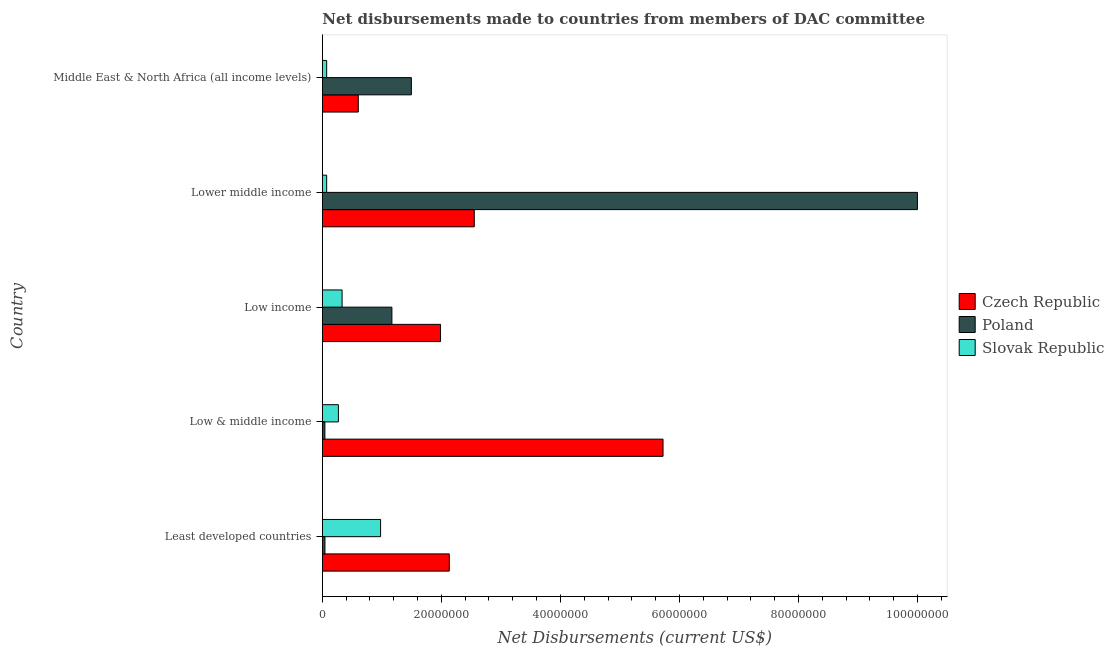How many groups of bars are there?
Your answer should be compact. 5. Are the number of bars per tick equal to the number of legend labels?
Your answer should be very brief. Yes. How many bars are there on the 3rd tick from the top?
Give a very brief answer. 3. How many bars are there on the 3rd tick from the bottom?
Your response must be concise. 3. What is the label of the 1st group of bars from the top?
Your answer should be very brief. Middle East & North Africa (all income levels). In how many cases, is the number of bars for a given country not equal to the number of legend labels?
Provide a short and direct response. 0. What is the net disbursements made by czech republic in Low income?
Provide a succinct answer. 1.99e+07. Across all countries, what is the maximum net disbursements made by czech republic?
Your response must be concise. 5.72e+07. Across all countries, what is the minimum net disbursements made by poland?
Ensure brevity in your answer.  4.30e+05. In which country was the net disbursements made by czech republic maximum?
Provide a short and direct response. Low & middle income. In which country was the net disbursements made by czech republic minimum?
Your answer should be compact. Middle East & North Africa (all income levels). What is the total net disbursements made by czech republic in the graph?
Your response must be concise. 1.30e+08. What is the difference between the net disbursements made by poland in Least developed countries and that in Low income?
Your answer should be very brief. -1.12e+07. What is the difference between the net disbursements made by poland in Least developed countries and the net disbursements made by slovak republic in Middle East & North Africa (all income levels)?
Make the answer very short. -2.90e+05. What is the average net disbursements made by czech republic per country?
Keep it short and to the point. 2.60e+07. What is the difference between the net disbursements made by czech republic and net disbursements made by poland in Low & middle income?
Provide a short and direct response. 5.68e+07. What is the ratio of the net disbursements made by slovak republic in Least developed countries to that in Low & middle income?
Offer a terse response. 3.63. What is the difference between the highest and the second highest net disbursements made by poland?
Ensure brevity in your answer.  8.50e+07. What is the difference between the highest and the lowest net disbursements made by poland?
Offer a very short reply. 9.96e+07. In how many countries, is the net disbursements made by poland greater than the average net disbursements made by poland taken over all countries?
Give a very brief answer. 1. Is the sum of the net disbursements made by czech republic in Low income and Middle East & North Africa (all income levels) greater than the maximum net disbursements made by slovak republic across all countries?
Provide a short and direct response. Yes. What does the 2nd bar from the bottom in Low & middle income represents?
Offer a very short reply. Poland. Are all the bars in the graph horizontal?
Ensure brevity in your answer.  Yes. Are the values on the major ticks of X-axis written in scientific E-notation?
Make the answer very short. No. How many legend labels are there?
Your response must be concise. 3. How are the legend labels stacked?
Offer a terse response. Vertical. What is the title of the graph?
Keep it short and to the point. Net disbursements made to countries from members of DAC committee. Does "Maunufacturing" appear as one of the legend labels in the graph?
Your answer should be very brief. No. What is the label or title of the X-axis?
Offer a terse response. Net Disbursements (current US$). What is the Net Disbursements (current US$) in Czech Republic in Least developed countries?
Your response must be concise. 2.13e+07. What is the Net Disbursements (current US$) in Slovak Republic in Least developed countries?
Your answer should be very brief. 9.79e+06. What is the Net Disbursements (current US$) of Czech Republic in Low & middle income?
Provide a succinct answer. 5.72e+07. What is the Net Disbursements (current US$) in Poland in Low & middle income?
Your answer should be very brief. 4.30e+05. What is the Net Disbursements (current US$) in Slovak Republic in Low & middle income?
Your answer should be very brief. 2.70e+06. What is the Net Disbursements (current US$) of Czech Republic in Low income?
Your answer should be compact. 1.99e+07. What is the Net Disbursements (current US$) in Poland in Low income?
Keep it short and to the point. 1.17e+07. What is the Net Disbursements (current US$) in Slovak Republic in Low income?
Offer a very short reply. 3.32e+06. What is the Net Disbursements (current US$) of Czech Republic in Lower middle income?
Keep it short and to the point. 2.55e+07. What is the Net Disbursements (current US$) in Poland in Lower middle income?
Offer a terse response. 1.00e+08. What is the Net Disbursements (current US$) in Slovak Republic in Lower middle income?
Offer a terse response. 7.30e+05. What is the Net Disbursements (current US$) in Czech Republic in Middle East & North Africa (all income levels)?
Ensure brevity in your answer.  6.04e+06. What is the Net Disbursements (current US$) of Poland in Middle East & North Africa (all income levels)?
Provide a short and direct response. 1.50e+07. What is the Net Disbursements (current US$) of Slovak Republic in Middle East & North Africa (all income levels)?
Provide a short and direct response. 7.30e+05. Across all countries, what is the maximum Net Disbursements (current US$) of Czech Republic?
Keep it short and to the point. 5.72e+07. Across all countries, what is the maximum Net Disbursements (current US$) in Poland?
Your answer should be compact. 1.00e+08. Across all countries, what is the maximum Net Disbursements (current US$) in Slovak Republic?
Offer a very short reply. 9.79e+06. Across all countries, what is the minimum Net Disbursements (current US$) of Czech Republic?
Keep it short and to the point. 6.04e+06. Across all countries, what is the minimum Net Disbursements (current US$) of Slovak Republic?
Make the answer very short. 7.30e+05. What is the total Net Disbursements (current US$) in Czech Republic in the graph?
Provide a succinct answer. 1.30e+08. What is the total Net Disbursements (current US$) of Poland in the graph?
Ensure brevity in your answer.  1.28e+08. What is the total Net Disbursements (current US$) in Slovak Republic in the graph?
Your answer should be compact. 1.73e+07. What is the difference between the Net Disbursements (current US$) of Czech Republic in Least developed countries and that in Low & middle income?
Provide a short and direct response. -3.59e+07. What is the difference between the Net Disbursements (current US$) in Slovak Republic in Least developed countries and that in Low & middle income?
Ensure brevity in your answer.  7.09e+06. What is the difference between the Net Disbursements (current US$) in Czech Republic in Least developed countries and that in Low income?
Give a very brief answer. 1.47e+06. What is the difference between the Net Disbursements (current US$) in Poland in Least developed countries and that in Low income?
Keep it short and to the point. -1.12e+07. What is the difference between the Net Disbursements (current US$) of Slovak Republic in Least developed countries and that in Low income?
Ensure brevity in your answer.  6.47e+06. What is the difference between the Net Disbursements (current US$) in Czech Republic in Least developed countries and that in Lower middle income?
Your answer should be very brief. -4.20e+06. What is the difference between the Net Disbursements (current US$) of Poland in Least developed countries and that in Lower middle income?
Give a very brief answer. -9.95e+07. What is the difference between the Net Disbursements (current US$) in Slovak Republic in Least developed countries and that in Lower middle income?
Your answer should be very brief. 9.06e+06. What is the difference between the Net Disbursements (current US$) of Czech Republic in Least developed countries and that in Middle East & North Africa (all income levels)?
Provide a short and direct response. 1.53e+07. What is the difference between the Net Disbursements (current US$) of Poland in Least developed countries and that in Middle East & North Africa (all income levels)?
Provide a succinct answer. -1.45e+07. What is the difference between the Net Disbursements (current US$) in Slovak Republic in Least developed countries and that in Middle East & North Africa (all income levels)?
Provide a short and direct response. 9.06e+06. What is the difference between the Net Disbursements (current US$) in Czech Republic in Low & middle income and that in Low income?
Make the answer very short. 3.74e+07. What is the difference between the Net Disbursements (current US$) in Poland in Low & middle income and that in Low income?
Ensure brevity in your answer.  -1.13e+07. What is the difference between the Net Disbursements (current US$) of Slovak Republic in Low & middle income and that in Low income?
Your answer should be very brief. -6.20e+05. What is the difference between the Net Disbursements (current US$) of Czech Republic in Low & middle income and that in Lower middle income?
Offer a very short reply. 3.17e+07. What is the difference between the Net Disbursements (current US$) in Poland in Low & middle income and that in Lower middle income?
Make the answer very short. -9.96e+07. What is the difference between the Net Disbursements (current US$) in Slovak Republic in Low & middle income and that in Lower middle income?
Your response must be concise. 1.97e+06. What is the difference between the Net Disbursements (current US$) in Czech Republic in Low & middle income and that in Middle East & North Africa (all income levels)?
Keep it short and to the point. 5.12e+07. What is the difference between the Net Disbursements (current US$) in Poland in Low & middle income and that in Middle East & North Africa (all income levels)?
Offer a very short reply. -1.45e+07. What is the difference between the Net Disbursements (current US$) of Slovak Republic in Low & middle income and that in Middle East & North Africa (all income levels)?
Your answer should be compact. 1.97e+06. What is the difference between the Net Disbursements (current US$) of Czech Republic in Low income and that in Lower middle income?
Your answer should be compact. -5.67e+06. What is the difference between the Net Disbursements (current US$) in Poland in Low income and that in Lower middle income?
Offer a terse response. -8.83e+07. What is the difference between the Net Disbursements (current US$) in Slovak Republic in Low income and that in Lower middle income?
Make the answer very short. 2.59e+06. What is the difference between the Net Disbursements (current US$) of Czech Republic in Low income and that in Middle East & North Africa (all income levels)?
Ensure brevity in your answer.  1.38e+07. What is the difference between the Net Disbursements (current US$) of Poland in Low income and that in Middle East & North Africa (all income levels)?
Provide a succinct answer. -3.27e+06. What is the difference between the Net Disbursements (current US$) in Slovak Republic in Low income and that in Middle East & North Africa (all income levels)?
Give a very brief answer. 2.59e+06. What is the difference between the Net Disbursements (current US$) in Czech Republic in Lower middle income and that in Middle East & North Africa (all income levels)?
Make the answer very short. 1.95e+07. What is the difference between the Net Disbursements (current US$) of Poland in Lower middle income and that in Middle East & North Africa (all income levels)?
Keep it short and to the point. 8.50e+07. What is the difference between the Net Disbursements (current US$) of Slovak Republic in Lower middle income and that in Middle East & North Africa (all income levels)?
Keep it short and to the point. 0. What is the difference between the Net Disbursements (current US$) in Czech Republic in Least developed countries and the Net Disbursements (current US$) in Poland in Low & middle income?
Ensure brevity in your answer.  2.09e+07. What is the difference between the Net Disbursements (current US$) of Czech Republic in Least developed countries and the Net Disbursements (current US$) of Slovak Republic in Low & middle income?
Your answer should be compact. 1.86e+07. What is the difference between the Net Disbursements (current US$) of Poland in Least developed countries and the Net Disbursements (current US$) of Slovak Republic in Low & middle income?
Make the answer very short. -2.26e+06. What is the difference between the Net Disbursements (current US$) of Czech Republic in Least developed countries and the Net Disbursements (current US$) of Poland in Low income?
Offer a very short reply. 9.64e+06. What is the difference between the Net Disbursements (current US$) in Czech Republic in Least developed countries and the Net Disbursements (current US$) in Slovak Republic in Low income?
Keep it short and to the point. 1.80e+07. What is the difference between the Net Disbursements (current US$) of Poland in Least developed countries and the Net Disbursements (current US$) of Slovak Republic in Low income?
Give a very brief answer. -2.88e+06. What is the difference between the Net Disbursements (current US$) of Czech Republic in Least developed countries and the Net Disbursements (current US$) of Poland in Lower middle income?
Ensure brevity in your answer.  -7.86e+07. What is the difference between the Net Disbursements (current US$) in Czech Republic in Least developed countries and the Net Disbursements (current US$) in Slovak Republic in Lower middle income?
Give a very brief answer. 2.06e+07. What is the difference between the Net Disbursements (current US$) of Czech Republic in Least developed countries and the Net Disbursements (current US$) of Poland in Middle East & North Africa (all income levels)?
Keep it short and to the point. 6.37e+06. What is the difference between the Net Disbursements (current US$) of Czech Republic in Least developed countries and the Net Disbursements (current US$) of Slovak Republic in Middle East & North Africa (all income levels)?
Give a very brief answer. 2.06e+07. What is the difference between the Net Disbursements (current US$) of Poland in Least developed countries and the Net Disbursements (current US$) of Slovak Republic in Middle East & North Africa (all income levels)?
Your response must be concise. -2.90e+05. What is the difference between the Net Disbursements (current US$) in Czech Republic in Low & middle income and the Net Disbursements (current US$) in Poland in Low income?
Provide a succinct answer. 4.56e+07. What is the difference between the Net Disbursements (current US$) in Czech Republic in Low & middle income and the Net Disbursements (current US$) in Slovak Republic in Low income?
Your answer should be very brief. 5.39e+07. What is the difference between the Net Disbursements (current US$) of Poland in Low & middle income and the Net Disbursements (current US$) of Slovak Republic in Low income?
Provide a short and direct response. -2.89e+06. What is the difference between the Net Disbursements (current US$) in Czech Republic in Low & middle income and the Net Disbursements (current US$) in Poland in Lower middle income?
Offer a terse response. -4.27e+07. What is the difference between the Net Disbursements (current US$) in Czech Republic in Low & middle income and the Net Disbursements (current US$) in Slovak Republic in Lower middle income?
Give a very brief answer. 5.65e+07. What is the difference between the Net Disbursements (current US$) of Czech Republic in Low & middle income and the Net Disbursements (current US$) of Poland in Middle East & North Africa (all income levels)?
Your answer should be compact. 4.23e+07. What is the difference between the Net Disbursements (current US$) in Czech Republic in Low & middle income and the Net Disbursements (current US$) in Slovak Republic in Middle East & North Africa (all income levels)?
Your response must be concise. 5.65e+07. What is the difference between the Net Disbursements (current US$) in Czech Republic in Low income and the Net Disbursements (current US$) in Poland in Lower middle income?
Give a very brief answer. -8.01e+07. What is the difference between the Net Disbursements (current US$) in Czech Republic in Low income and the Net Disbursements (current US$) in Slovak Republic in Lower middle income?
Your answer should be very brief. 1.91e+07. What is the difference between the Net Disbursements (current US$) in Poland in Low income and the Net Disbursements (current US$) in Slovak Republic in Lower middle income?
Ensure brevity in your answer.  1.10e+07. What is the difference between the Net Disbursements (current US$) in Czech Republic in Low income and the Net Disbursements (current US$) in Poland in Middle East & North Africa (all income levels)?
Your answer should be compact. 4.90e+06. What is the difference between the Net Disbursements (current US$) of Czech Republic in Low income and the Net Disbursements (current US$) of Slovak Republic in Middle East & North Africa (all income levels)?
Give a very brief answer. 1.91e+07. What is the difference between the Net Disbursements (current US$) in Poland in Low income and the Net Disbursements (current US$) in Slovak Republic in Middle East & North Africa (all income levels)?
Offer a very short reply. 1.10e+07. What is the difference between the Net Disbursements (current US$) of Czech Republic in Lower middle income and the Net Disbursements (current US$) of Poland in Middle East & North Africa (all income levels)?
Your response must be concise. 1.06e+07. What is the difference between the Net Disbursements (current US$) in Czech Republic in Lower middle income and the Net Disbursements (current US$) in Slovak Republic in Middle East & North Africa (all income levels)?
Give a very brief answer. 2.48e+07. What is the difference between the Net Disbursements (current US$) of Poland in Lower middle income and the Net Disbursements (current US$) of Slovak Republic in Middle East & North Africa (all income levels)?
Ensure brevity in your answer.  9.92e+07. What is the average Net Disbursements (current US$) in Czech Republic per country?
Keep it short and to the point. 2.60e+07. What is the average Net Disbursements (current US$) of Poland per country?
Your answer should be compact. 2.55e+07. What is the average Net Disbursements (current US$) in Slovak Republic per country?
Ensure brevity in your answer.  3.45e+06. What is the difference between the Net Disbursements (current US$) of Czech Republic and Net Disbursements (current US$) of Poland in Least developed countries?
Your answer should be very brief. 2.09e+07. What is the difference between the Net Disbursements (current US$) of Czech Republic and Net Disbursements (current US$) of Slovak Republic in Least developed countries?
Ensure brevity in your answer.  1.15e+07. What is the difference between the Net Disbursements (current US$) in Poland and Net Disbursements (current US$) in Slovak Republic in Least developed countries?
Provide a succinct answer. -9.35e+06. What is the difference between the Net Disbursements (current US$) in Czech Republic and Net Disbursements (current US$) in Poland in Low & middle income?
Make the answer very short. 5.68e+07. What is the difference between the Net Disbursements (current US$) of Czech Republic and Net Disbursements (current US$) of Slovak Republic in Low & middle income?
Provide a short and direct response. 5.45e+07. What is the difference between the Net Disbursements (current US$) in Poland and Net Disbursements (current US$) in Slovak Republic in Low & middle income?
Make the answer very short. -2.27e+06. What is the difference between the Net Disbursements (current US$) in Czech Republic and Net Disbursements (current US$) in Poland in Low income?
Your answer should be compact. 8.17e+06. What is the difference between the Net Disbursements (current US$) in Czech Republic and Net Disbursements (current US$) in Slovak Republic in Low income?
Provide a short and direct response. 1.65e+07. What is the difference between the Net Disbursements (current US$) of Poland and Net Disbursements (current US$) of Slovak Republic in Low income?
Provide a short and direct response. 8.37e+06. What is the difference between the Net Disbursements (current US$) in Czech Republic and Net Disbursements (current US$) in Poland in Lower middle income?
Provide a short and direct response. -7.44e+07. What is the difference between the Net Disbursements (current US$) in Czech Republic and Net Disbursements (current US$) in Slovak Republic in Lower middle income?
Make the answer very short. 2.48e+07. What is the difference between the Net Disbursements (current US$) of Poland and Net Disbursements (current US$) of Slovak Republic in Lower middle income?
Give a very brief answer. 9.92e+07. What is the difference between the Net Disbursements (current US$) in Czech Republic and Net Disbursements (current US$) in Poland in Middle East & North Africa (all income levels)?
Offer a very short reply. -8.92e+06. What is the difference between the Net Disbursements (current US$) of Czech Republic and Net Disbursements (current US$) of Slovak Republic in Middle East & North Africa (all income levels)?
Your response must be concise. 5.31e+06. What is the difference between the Net Disbursements (current US$) of Poland and Net Disbursements (current US$) of Slovak Republic in Middle East & North Africa (all income levels)?
Your response must be concise. 1.42e+07. What is the ratio of the Net Disbursements (current US$) of Czech Republic in Least developed countries to that in Low & middle income?
Give a very brief answer. 0.37. What is the ratio of the Net Disbursements (current US$) of Poland in Least developed countries to that in Low & middle income?
Provide a succinct answer. 1.02. What is the ratio of the Net Disbursements (current US$) of Slovak Republic in Least developed countries to that in Low & middle income?
Your answer should be very brief. 3.63. What is the ratio of the Net Disbursements (current US$) in Czech Republic in Least developed countries to that in Low income?
Your answer should be compact. 1.07. What is the ratio of the Net Disbursements (current US$) of Poland in Least developed countries to that in Low income?
Make the answer very short. 0.04. What is the ratio of the Net Disbursements (current US$) in Slovak Republic in Least developed countries to that in Low income?
Offer a terse response. 2.95. What is the ratio of the Net Disbursements (current US$) of Czech Republic in Least developed countries to that in Lower middle income?
Keep it short and to the point. 0.84. What is the ratio of the Net Disbursements (current US$) in Poland in Least developed countries to that in Lower middle income?
Provide a succinct answer. 0. What is the ratio of the Net Disbursements (current US$) of Slovak Republic in Least developed countries to that in Lower middle income?
Ensure brevity in your answer.  13.41. What is the ratio of the Net Disbursements (current US$) in Czech Republic in Least developed countries to that in Middle East & North Africa (all income levels)?
Your response must be concise. 3.53. What is the ratio of the Net Disbursements (current US$) of Poland in Least developed countries to that in Middle East & North Africa (all income levels)?
Make the answer very short. 0.03. What is the ratio of the Net Disbursements (current US$) in Slovak Republic in Least developed countries to that in Middle East & North Africa (all income levels)?
Offer a terse response. 13.41. What is the ratio of the Net Disbursements (current US$) of Czech Republic in Low & middle income to that in Low income?
Provide a succinct answer. 2.88. What is the ratio of the Net Disbursements (current US$) of Poland in Low & middle income to that in Low income?
Ensure brevity in your answer.  0.04. What is the ratio of the Net Disbursements (current US$) in Slovak Republic in Low & middle income to that in Low income?
Ensure brevity in your answer.  0.81. What is the ratio of the Net Disbursements (current US$) of Czech Republic in Low & middle income to that in Lower middle income?
Offer a very short reply. 2.24. What is the ratio of the Net Disbursements (current US$) of Poland in Low & middle income to that in Lower middle income?
Your answer should be compact. 0. What is the ratio of the Net Disbursements (current US$) of Slovak Republic in Low & middle income to that in Lower middle income?
Offer a terse response. 3.7. What is the ratio of the Net Disbursements (current US$) of Czech Republic in Low & middle income to that in Middle East & North Africa (all income levels)?
Make the answer very short. 9.48. What is the ratio of the Net Disbursements (current US$) in Poland in Low & middle income to that in Middle East & North Africa (all income levels)?
Keep it short and to the point. 0.03. What is the ratio of the Net Disbursements (current US$) of Slovak Republic in Low & middle income to that in Middle East & North Africa (all income levels)?
Your answer should be very brief. 3.7. What is the ratio of the Net Disbursements (current US$) of Czech Republic in Low income to that in Lower middle income?
Keep it short and to the point. 0.78. What is the ratio of the Net Disbursements (current US$) in Poland in Low income to that in Lower middle income?
Ensure brevity in your answer.  0.12. What is the ratio of the Net Disbursements (current US$) in Slovak Republic in Low income to that in Lower middle income?
Your response must be concise. 4.55. What is the ratio of the Net Disbursements (current US$) in Czech Republic in Low income to that in Middle East & North Africa (all income levels)?
Ensure brevity in your answer.  3.29. What is the ratio of the Net Disbursements (current US$) of Poland in Low income to that in Middle East & North Africa (all income levels)?
Ensure brevity in your answer.  0.78. What is the ratio of the Net Disbursements (current US$) of Slovak Republic in Low income to that in Middle East & North Africa (all income levels)?
Ensure brevity in your answer.  4.55. What is the ratio of the Net Disbursements (current US$) of Czech Republic in Lower middle income to that in Middle East & North Africa (all income levels)?
Your answer should be very brief. 4.23. What is the ratio of the Net Disbursements (current US$) in Poland in Lower middle income to that in Middle East & North Africa (all income levels)?
Provide a short and direct response. 6.68. What is the difference between the highest and the second highest Net Disbursements (current US$) in Czech Republic?
Offer a terse response. 3.17e+07. What is the difference between the highest and the second highest Net Disbursements (current US$) of Poland?
Your answer should be compact. 8.50e+07. What is the difference between the highest and the second highest Net Disbursements (current US$) in Slovak Republic?
Ensure brevity in your answer.  6.47e+06. What is the difference between the highest and the lowest Net Disbursements (current US$) of Czech Republic?
Keep it short and to the point. 5.12e+07. What is the difference between the highest and the lowest Net Disbursements (current US$) in Poland?
Your answer should be very brief. 9.96e+07. What is the difference between the highest and the lowest Net Disbursements (current US$) of Slovak Republic?
Provide a short and direct response. 9.06e+06. 